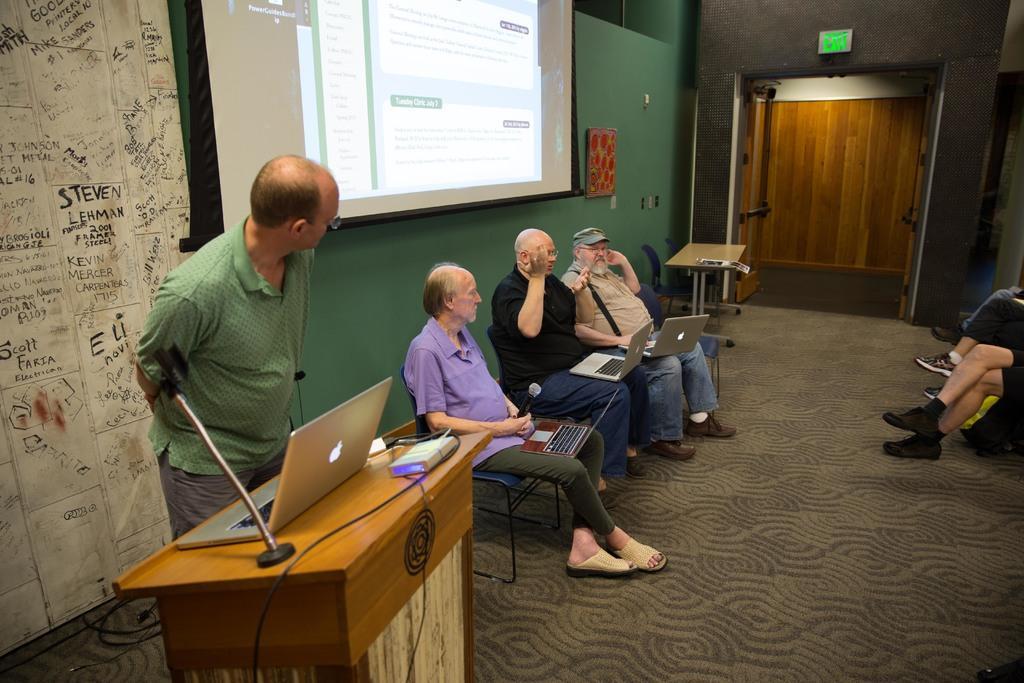Can you describe this image briefly? there are some people sitting on a chair operating a laptop and there is the other person standing behind the table is staring at them and there is a projector screen hanging from the top and there is a door open to the access 